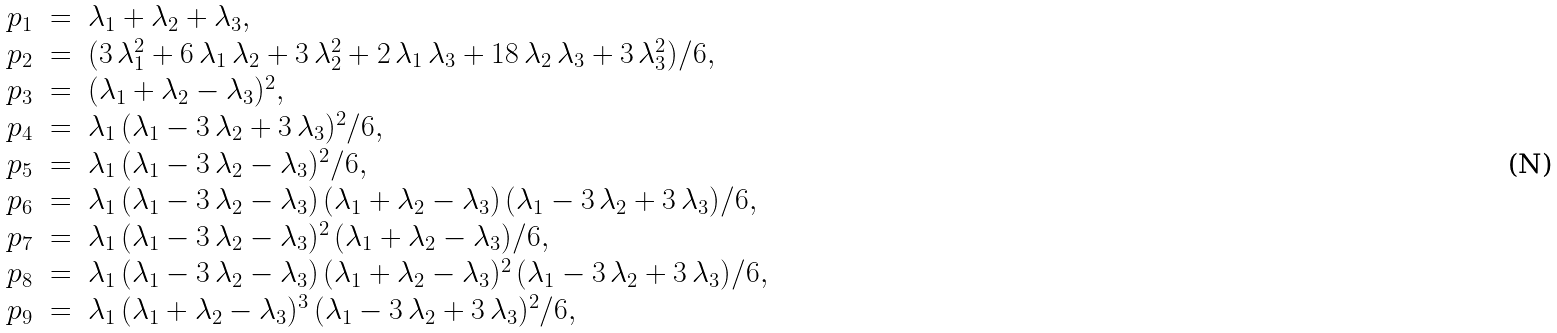Convert formula to latex. <formula><loc_0><loc_0><loc_500><loc_500>\begin{array} { r c l } p _ { 1 } & = & \lambda _ { 1 } + \lambda _ { 2 } + \lambda _ { 3 } , \\ p _ { 2 } & = & ( 3 \, \lambda _ { 1 } ^ { 2 } + 6 \, \lambda _ { 1 } \, \lambda _ { 2 } + 3 \, \lambda _ { 2 } ^ { 2 } + 2 \, \lambda _ { 1 } \, \lambda _ { 3 } + 1 8 \, \lambda _ { 2 } \, \lambda _ { 3 } + 3 \, \lambda _ { 3 } ^ { 2 } ) / 6 , \\ p _ { 3 } & = & ( \lambda _ { 1 } + \lambda _ { 2 } - \lambda _ { 3 } ) ^ { 2 } , \\ p _ { 4 } & = & \lambda _ { 1 } \, ( \lambda _ { 1 } - 3 \, \lambda _ { 2 } + 3 \, \lambda _ { 3 } ) ^ { 2 } / 6 , \\ p _ { 5 } & = & \lambda _ { 1 } \, ( \lambda _ { 1 } - 3 \, \lambda _ { 2 } - \lambda _ { 3 } ) ^ { 2 } / 6 , \\ p _ { 6 } & = & \lambda _ { 1 } \, ( \lambda _ { 1 } - 3 \, \lambda _ { 2 } - \lambda _ { 3 } ) \, ( \lambda _ { 1 } + \lambda _ { 2 } - \lambda _ { 3 } ) \, ( \lambda _ { 1 } - 3 \, \lambda _ { 2 } + 3 \, \lambda _ { 3 } ) / 6 , \\ p _ { 7 } & = & \lambda _ { 1 } \, ( \lambda _ { 1 } - 3 \, \lambda _ { 2 } - \lambda _ { 3 } ) ^ { 2 } \, ( \lambda _ { 1 } + \lambda _ { 2 } - \lambda _ { 3 } ) / 6 , \\ p _ { 8 } & = & \lambda _ { 1 } \, ( \lambda _ { 1 } - 3 \, \lambda _ { 2 } - \lambda _ { 3 } ) \, ( \lambda _ { 1 } + \lambda _ { 2 } - \lambda _ { 3 } ) ^ { 2 } \, ( \lambda _ { 1 } - 3 \, \lambda _ { 2 } + 3 \, \lambda _ { 3 } ) / 6 , \\ p _ { 9 } & = & \lambda _ { 1 } \, ( \lambda _ { 1 } + \lambda _ { 2 } - \lambda _ { 3 } ) ^ { 3 } \, ( \lambda _ { 1 } - 3 \, \lambda _ { 2 } + 3 \, \lambda _ { 3 } ) ^ { 2 } / 6 , \end{array}</formula> 